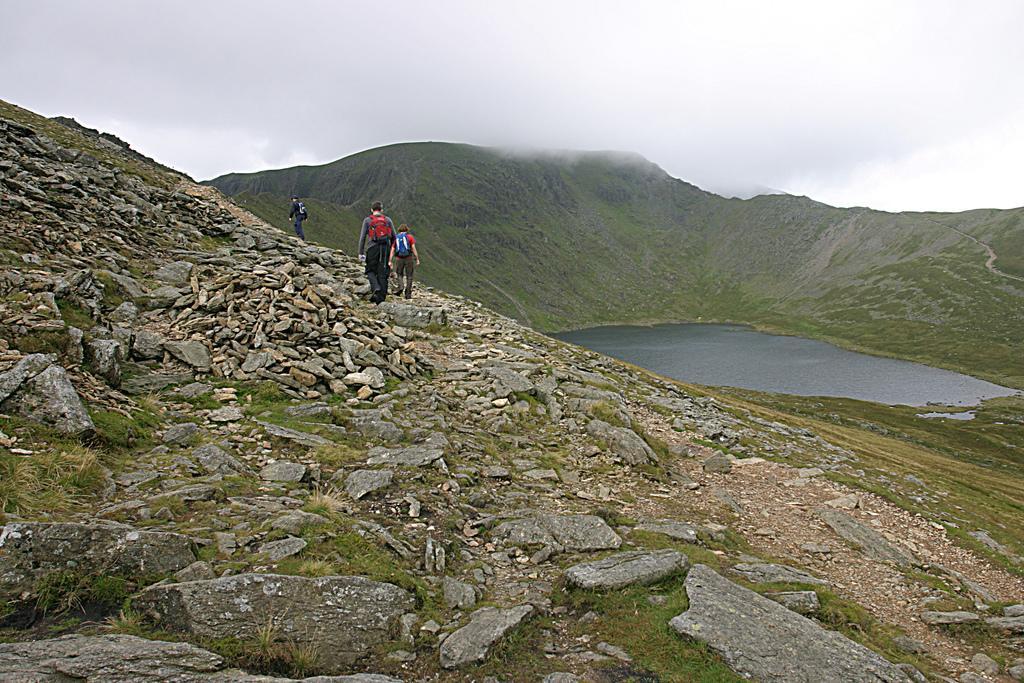Can you describe this image briefly? In this image there is water in the middle and there are hills around it. On the hills there are three people walking on it with their bags. On the hills there are stones and grass. At the top there is sky. 